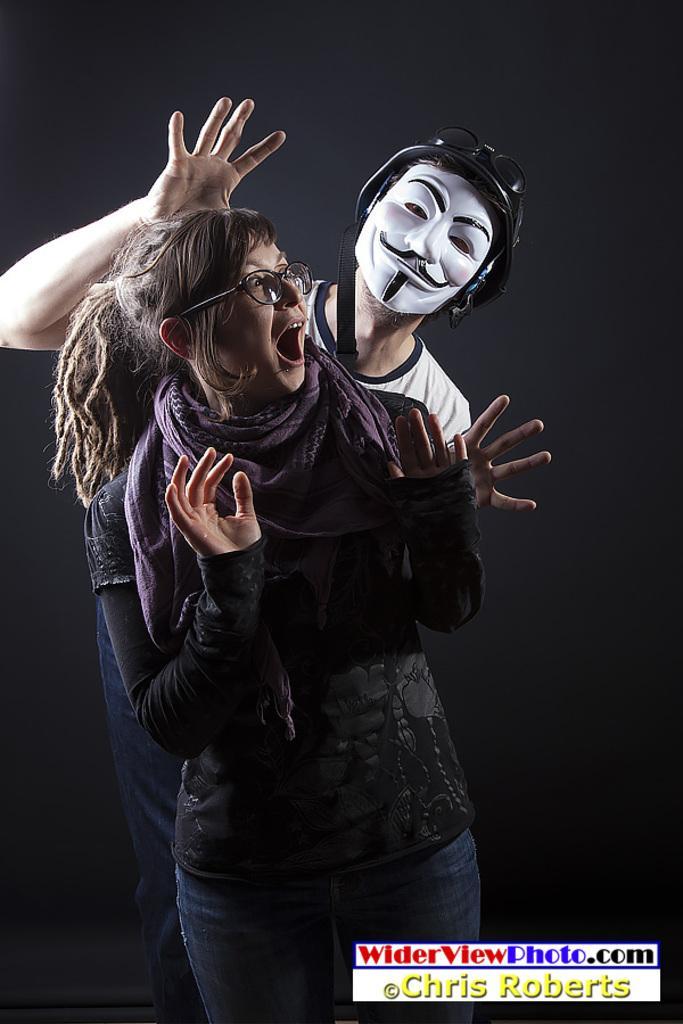Could you give a brief overview of what you see in this image? In this picture, there is a woman in the center. She is wearing a black top and purple scarf. Behind her, there is a man wearing a mask and white t shirt. At the bottom, there is a text. 